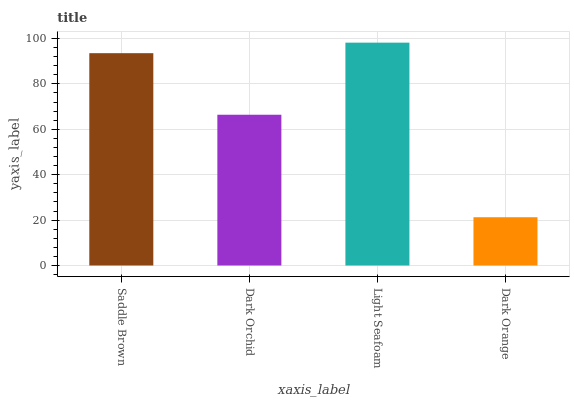Is Dark Orange the minimum?
Answer yes or no. Yes. Is Light Seafoam the maximum?
Answer yes or no. Yes. Is Dark Orchid the minimum?
Answer yes or no. No. Is Dark Orchid the maximum?
Answer yes or no. No. Is Saddle Brown greater than Dark Orchid?
Answer yes or no. Yes. Is Dark Orchid less than Saddle Brown?
Answer yes or no. Yes. Is Dark Orchid greater than Saddle Brown?
Answer yes or no. No. Is Saddle Brown less than Dark Orchid?
Answer yes or no. No. Is Saddle Brown the high median?
Answer yes or no. Yes. Is Dark Orchid the low median?
Answer yes or no. Yes. Is Dark Orange the high median?
Answer yes or no. No. Is Dark Orange the low median?
Answer yes or no. No. 